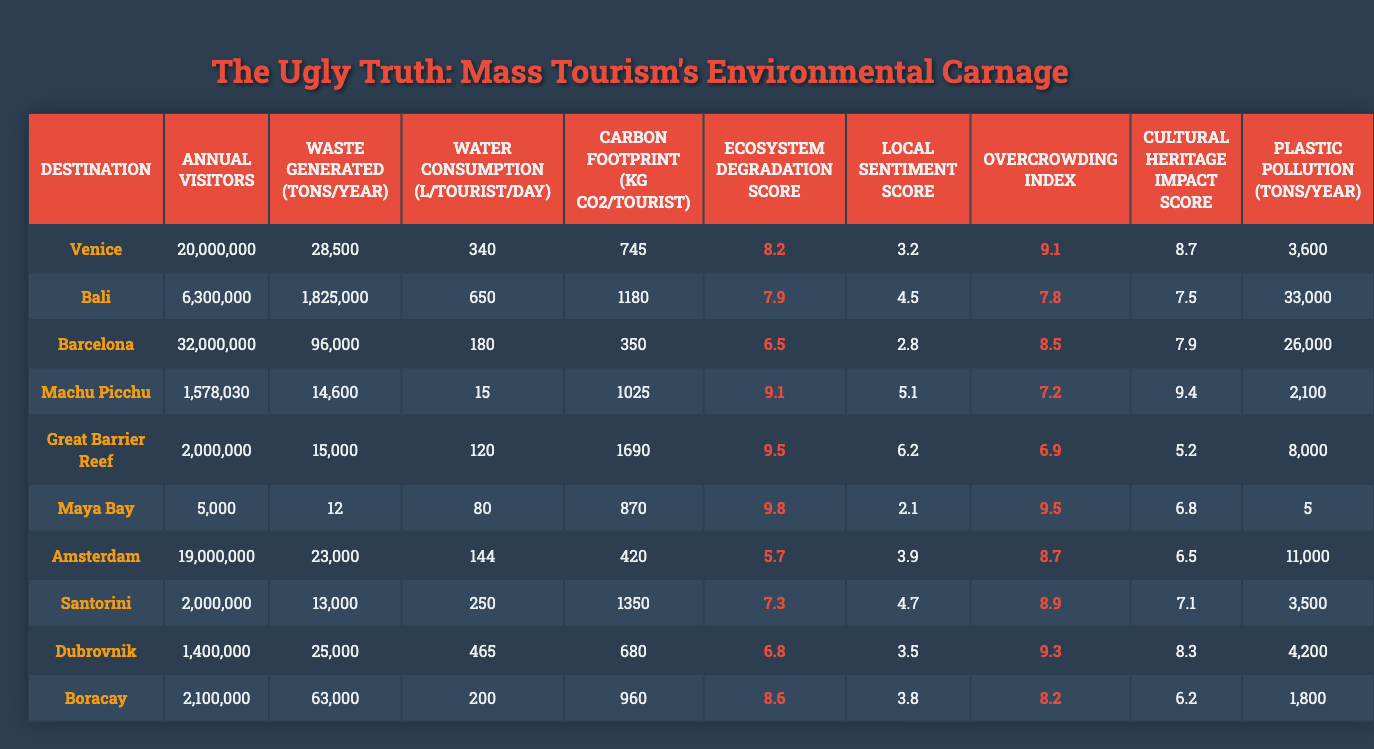What is the destination with the highest annual visitors? By examining the "Annual Visitors" column, we can see that Barcelona has the highest number of visitors at 32,000,000.
Answer: Barcelona Which destination generates the most waste per year? The "Waste Generated (tons/year)" column shows that Bali generates the most waste at 1,825,000 tons per year, which is significantly higher than any other destination.
Answer: Bali What is the local sentiment score for Venice? The "Local Sentiment Score" for Venice is listed as 3.2. This is directly taken from the score column.
Answer: 3.2 Which destination has the highest carbon footprint per tourist? The "Carbon Footprint (kg CO₂/tourist)" for the Great Barrier Reef is 1,690 kg, which is the highest among all destinations listed.
Answer: Great Barrier Reef What is the average ecosystem degradation score for all destinations? To find the average, sum the ecosystem degradation scores: (8.2 + 7.9 + 6.5 + 9.1 + 9.5 + 9.8 + 5.7 + 7.3 + 6.8 + 8.6) = 79.4, and then divide by the number of destinations (10), resulting in an average of 7.94.
Answer: 7.94 Is Maya Bay's plastic pollution lower than that of Dubrovnik? Maya Bay has 5 tons of plastic pollution while Dubrovnik has 4,200 tons. Since 5 is less than 4,200, the statement is false.
Answer: No Which destination has the lowest water consumption per tourist per day? By comparing the "Water Consumption (L/tourist/day)" values, Machu Picchu has the lowest figure at 15 liters, making it the destination with the least water consumption per tourist.
Answer: Machu Picchu If we consider overcrowding, which destination has the highest score? Looking at the "Overcrowding Index," Dubrovnik has the highest score of 9.3, indicating it experiences the most overcrowding among the listed destinations.
Answer: Dubrovnik What is the total waste generated by Venice, Bali, and Barcelona combined? Adding the waste generated values gives us: (28,500 + 1,825,000 + 96,000) = 1,949,500 tons; hence the total waste generated is 1,949,500 tons.
Answer: 1,949,500 tons Comparing cultural heritage impact scores, does Machu Picchu have a significantly higher impact than the Great Barrier Reef? Machu Picchu has a score of 9.4, while the Great Barrier Reef has a score of 5.2. Since 9.4 is greater than 5.2, the statement is true.
Answer: Yes 